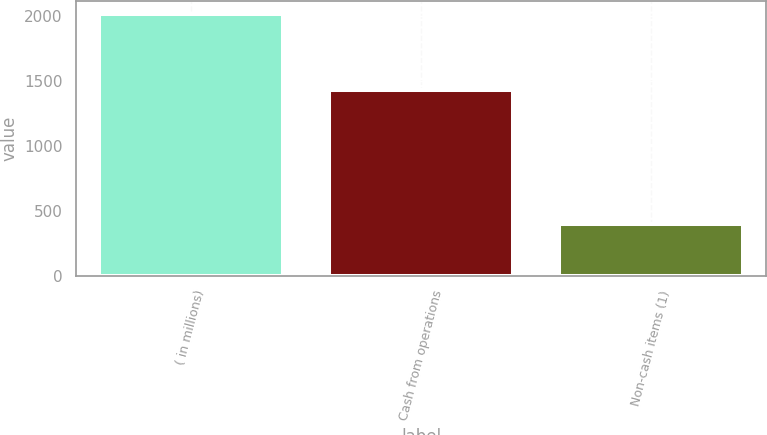Convert chart to OTSL. <chart><loc_0><loc_0><loc_500><loc_500><bar_chart><fcel>( in millions)<fcel>Cash from operations<fcel>Non-cash items (1)<nl><fcel>2015<fcel>1430<fcel>395<nl></chart> 